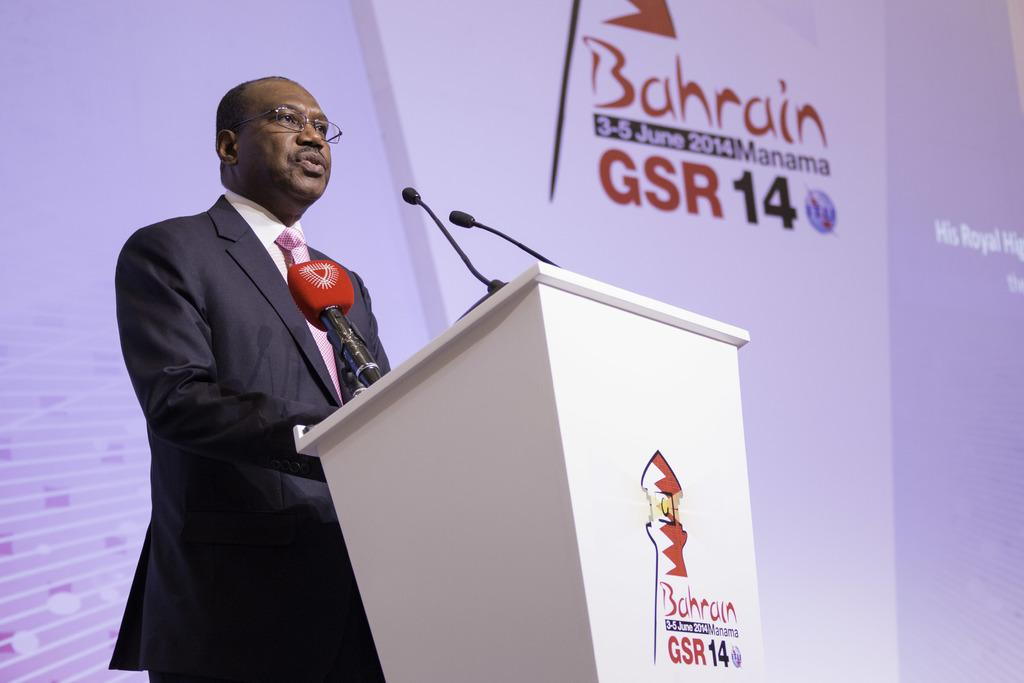Who is the main subject in the image? There is a man in the image. What is the man wearing? The man is wearing a black suit. What is the man doing in the image? The man is standing and giving a speech. What is in front of the man? There is a white color speech desk in front of the man. What can be seen in the background of the image? There is a white banner in the background of the image. Can you see any goldfish swimming in the background of the image? No, there are no goldfish present in the image. 